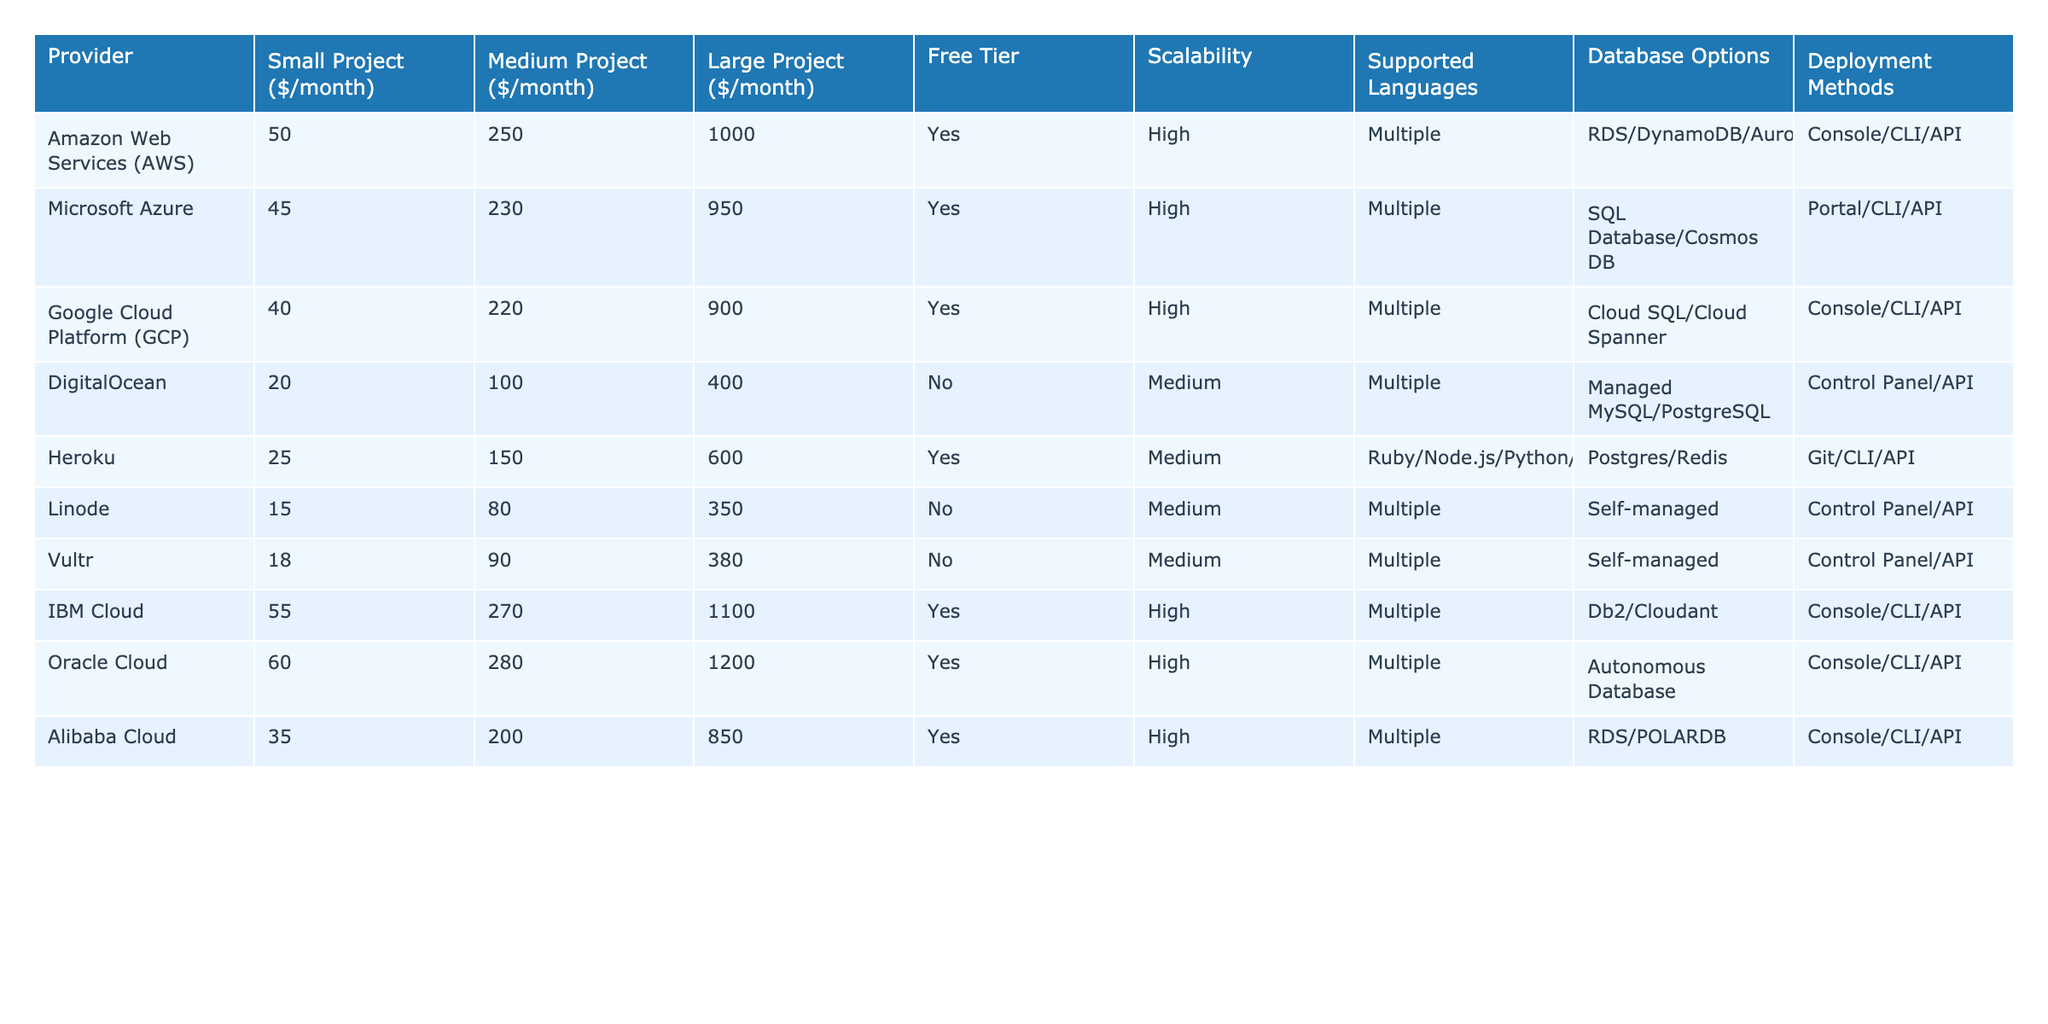What is the monthly cost for a small project using DigitalOcean? The monthly cost for a small project using DigitalOcean is listed in the "Small Project" column under the "DigitalOcean" row. The value is 20.
Answer: 20 Which provider has the highest cost for a large project? To find the provider with the highest cost for a large project, we look at the "Large Project" column and identify the maximum value. The highest cost is 1200 from Oracle Cloud.
Answer: Oracle Cloud What is the difference in cost between a medium project on AWS and GCP? To calculate the difference, take the cost of a medium project on AWS, which is 250, and the cost on GCP, which is 220. The difference is 250 - 220 = 30.
Answer: 30 Does DigitalOcean offer a free tier? The "Free Tier" column shows "No" for DigitalOcean, indicating that it does not provide a free tier.
Answer: No Which providers support multiple programming languages? The "Supported Languages" column can be scanned for the term "Multiple." AWS, Microsoft Azure, GCP, IBM Cloud, Oracle Cloud, and Alibaba Cloud all support multiple languages.
Answer: AWS, Microsoft Azure, GCP, IBM Cloud, Oracle Cloud, Alibaba Cloud What is the average monthly cost for a medium project across all providers? The average for medium projects is calculated by summing the costs (250 + 230 + 220 + 100 + 150 + 80 + 90 + 270 + 280 + 200) which equals 1870, and dividing by the number of providers (10). The average is 1870 / 10 = 187.
Answer: 187 Which provider has the lowest monthly cost for a large project? The lowest cost for a large project is found by looking at the "Large Project" column. The minimum value is 350 from Linode.
Answer: Linode Do all providers offer scalability? To determine scalability, check the "Scalability" column for any instances marked as "Low." Both DigitalOcean and Linode have "Medium" scalability, suggesting they do not offer high scalability. Hence, not all providers offer high scalability.
Answer: No Which provider has the highest cost for a small project and does it offer a free tier? The highest cost for a small project is 60 from Oracle Cloud. The "Free Tier" column shows "Yes," indicating it does offer a free tier.
Answer: Yes, 60 